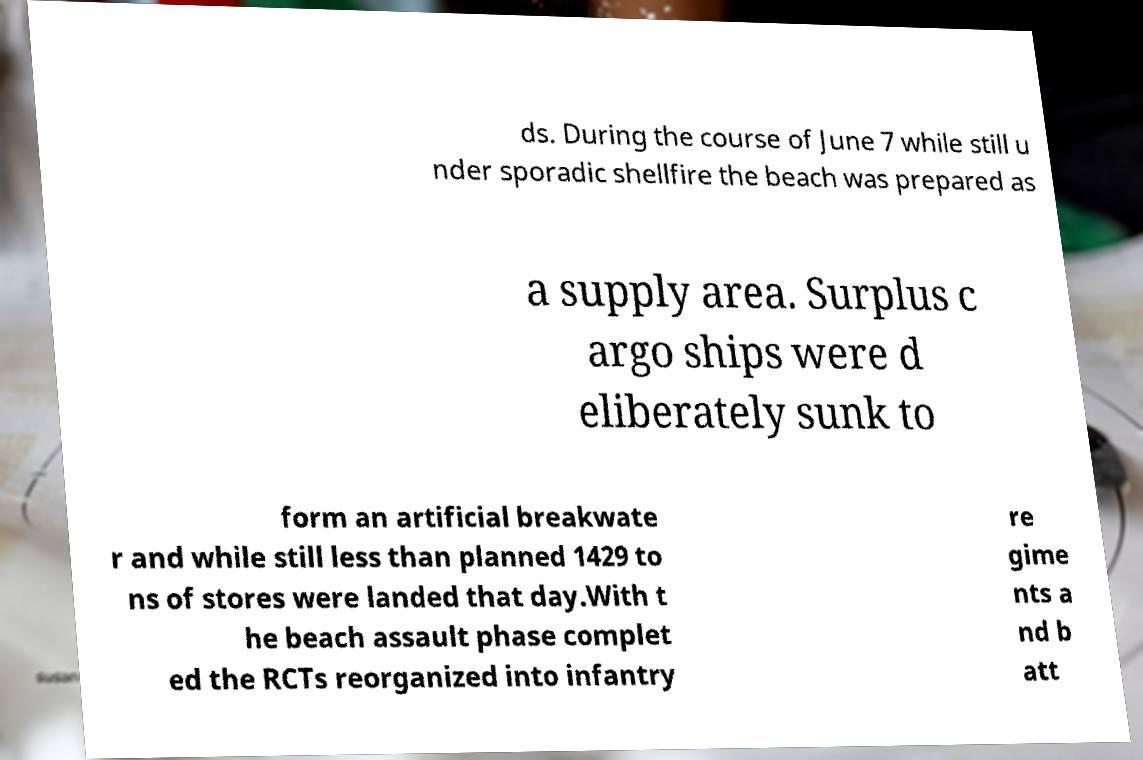Could you assist in decoding the text presented in this image and type it out clearly? ds. During the course of June 7 while still u nder sporadic shellfire the beach was prepared as a supply area. Surplus c argo ships were d eliberately sunk to form an artificial breakwate r and while still less than planned 1429 to ns of stores were landed that day.With t he beach assault phase complet ed the RCTs reorganized into infantry re gime nts a nd b att 